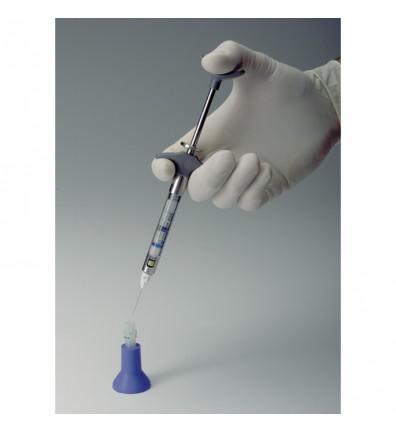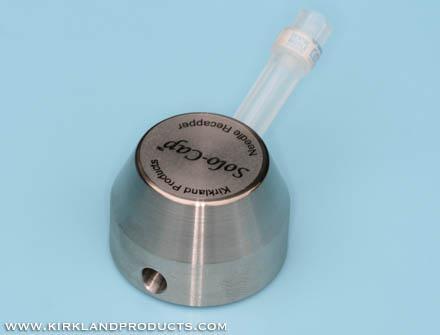The first image is the image on the left, the second image is the image on the right. Given the left and right images, does the statement "A person is inserting a syringe into an orange holder." hold true? Answer yes or no. No. 